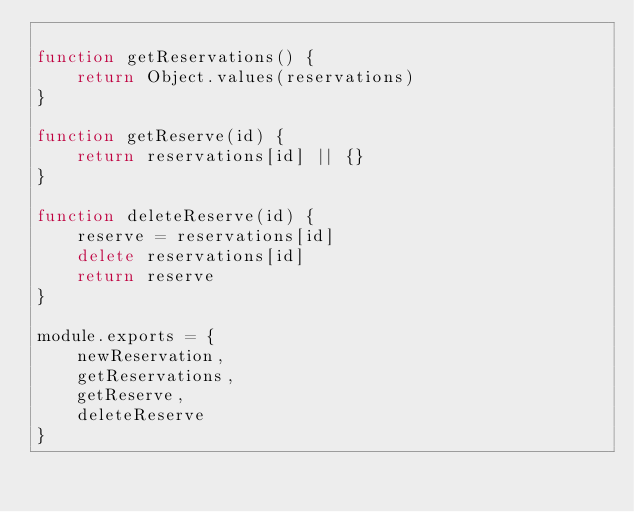<code> <loc_0><loc_0><loc_500><loc_500><_JavaScript_>
function getReservations() {
    return Object.values(reservations)
}

function getReserve(id) {
    return reservations[id] || {}
}

function deleteReserve(id) {
    reserve = reservations[id]
    delete reservations[id]
    return reserve
}

module.exports = {
    newReservation,
    getReservations,
    getReserve,
    deleteReserve
}

</code> 